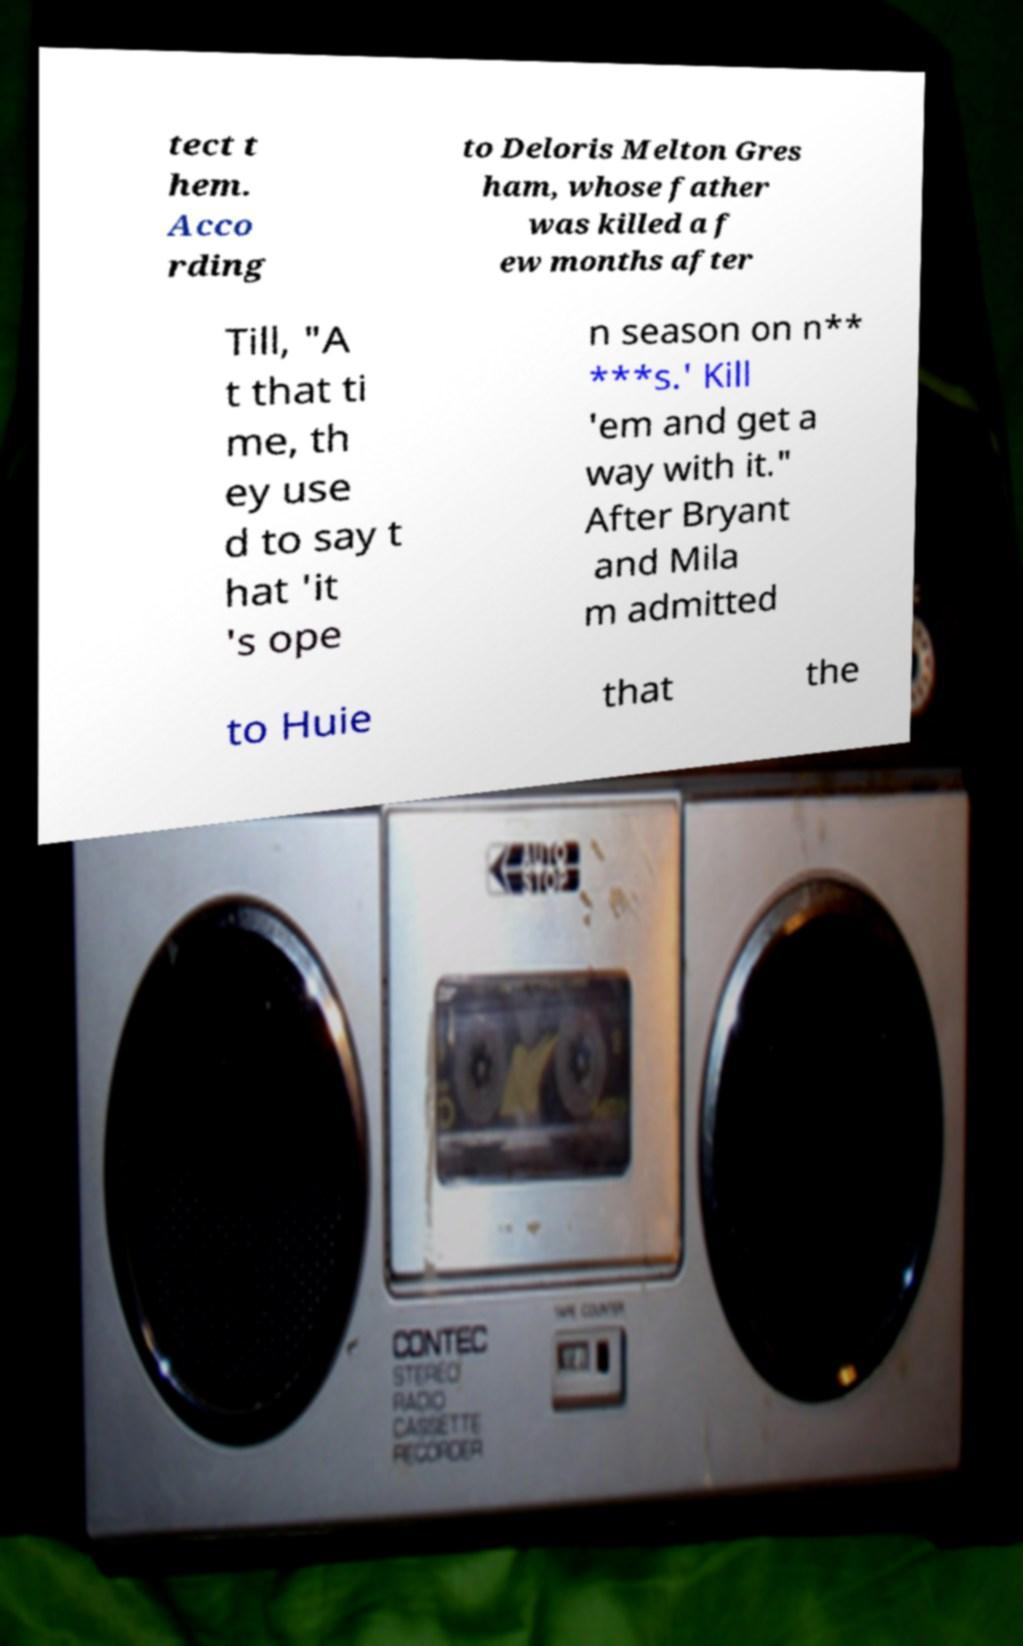Please read and relay the text visible in this image. What does it say? tect t hem. Acco rding to Deloris Melton Gres ham, whose father was killed a f ew months after Till, "A t that ti me, th ey use d to say t hat 'it 's ope n season on n** ***s.' Kill 'em and get a way with it." After Bryant and Mila m admitted to Huie that the 